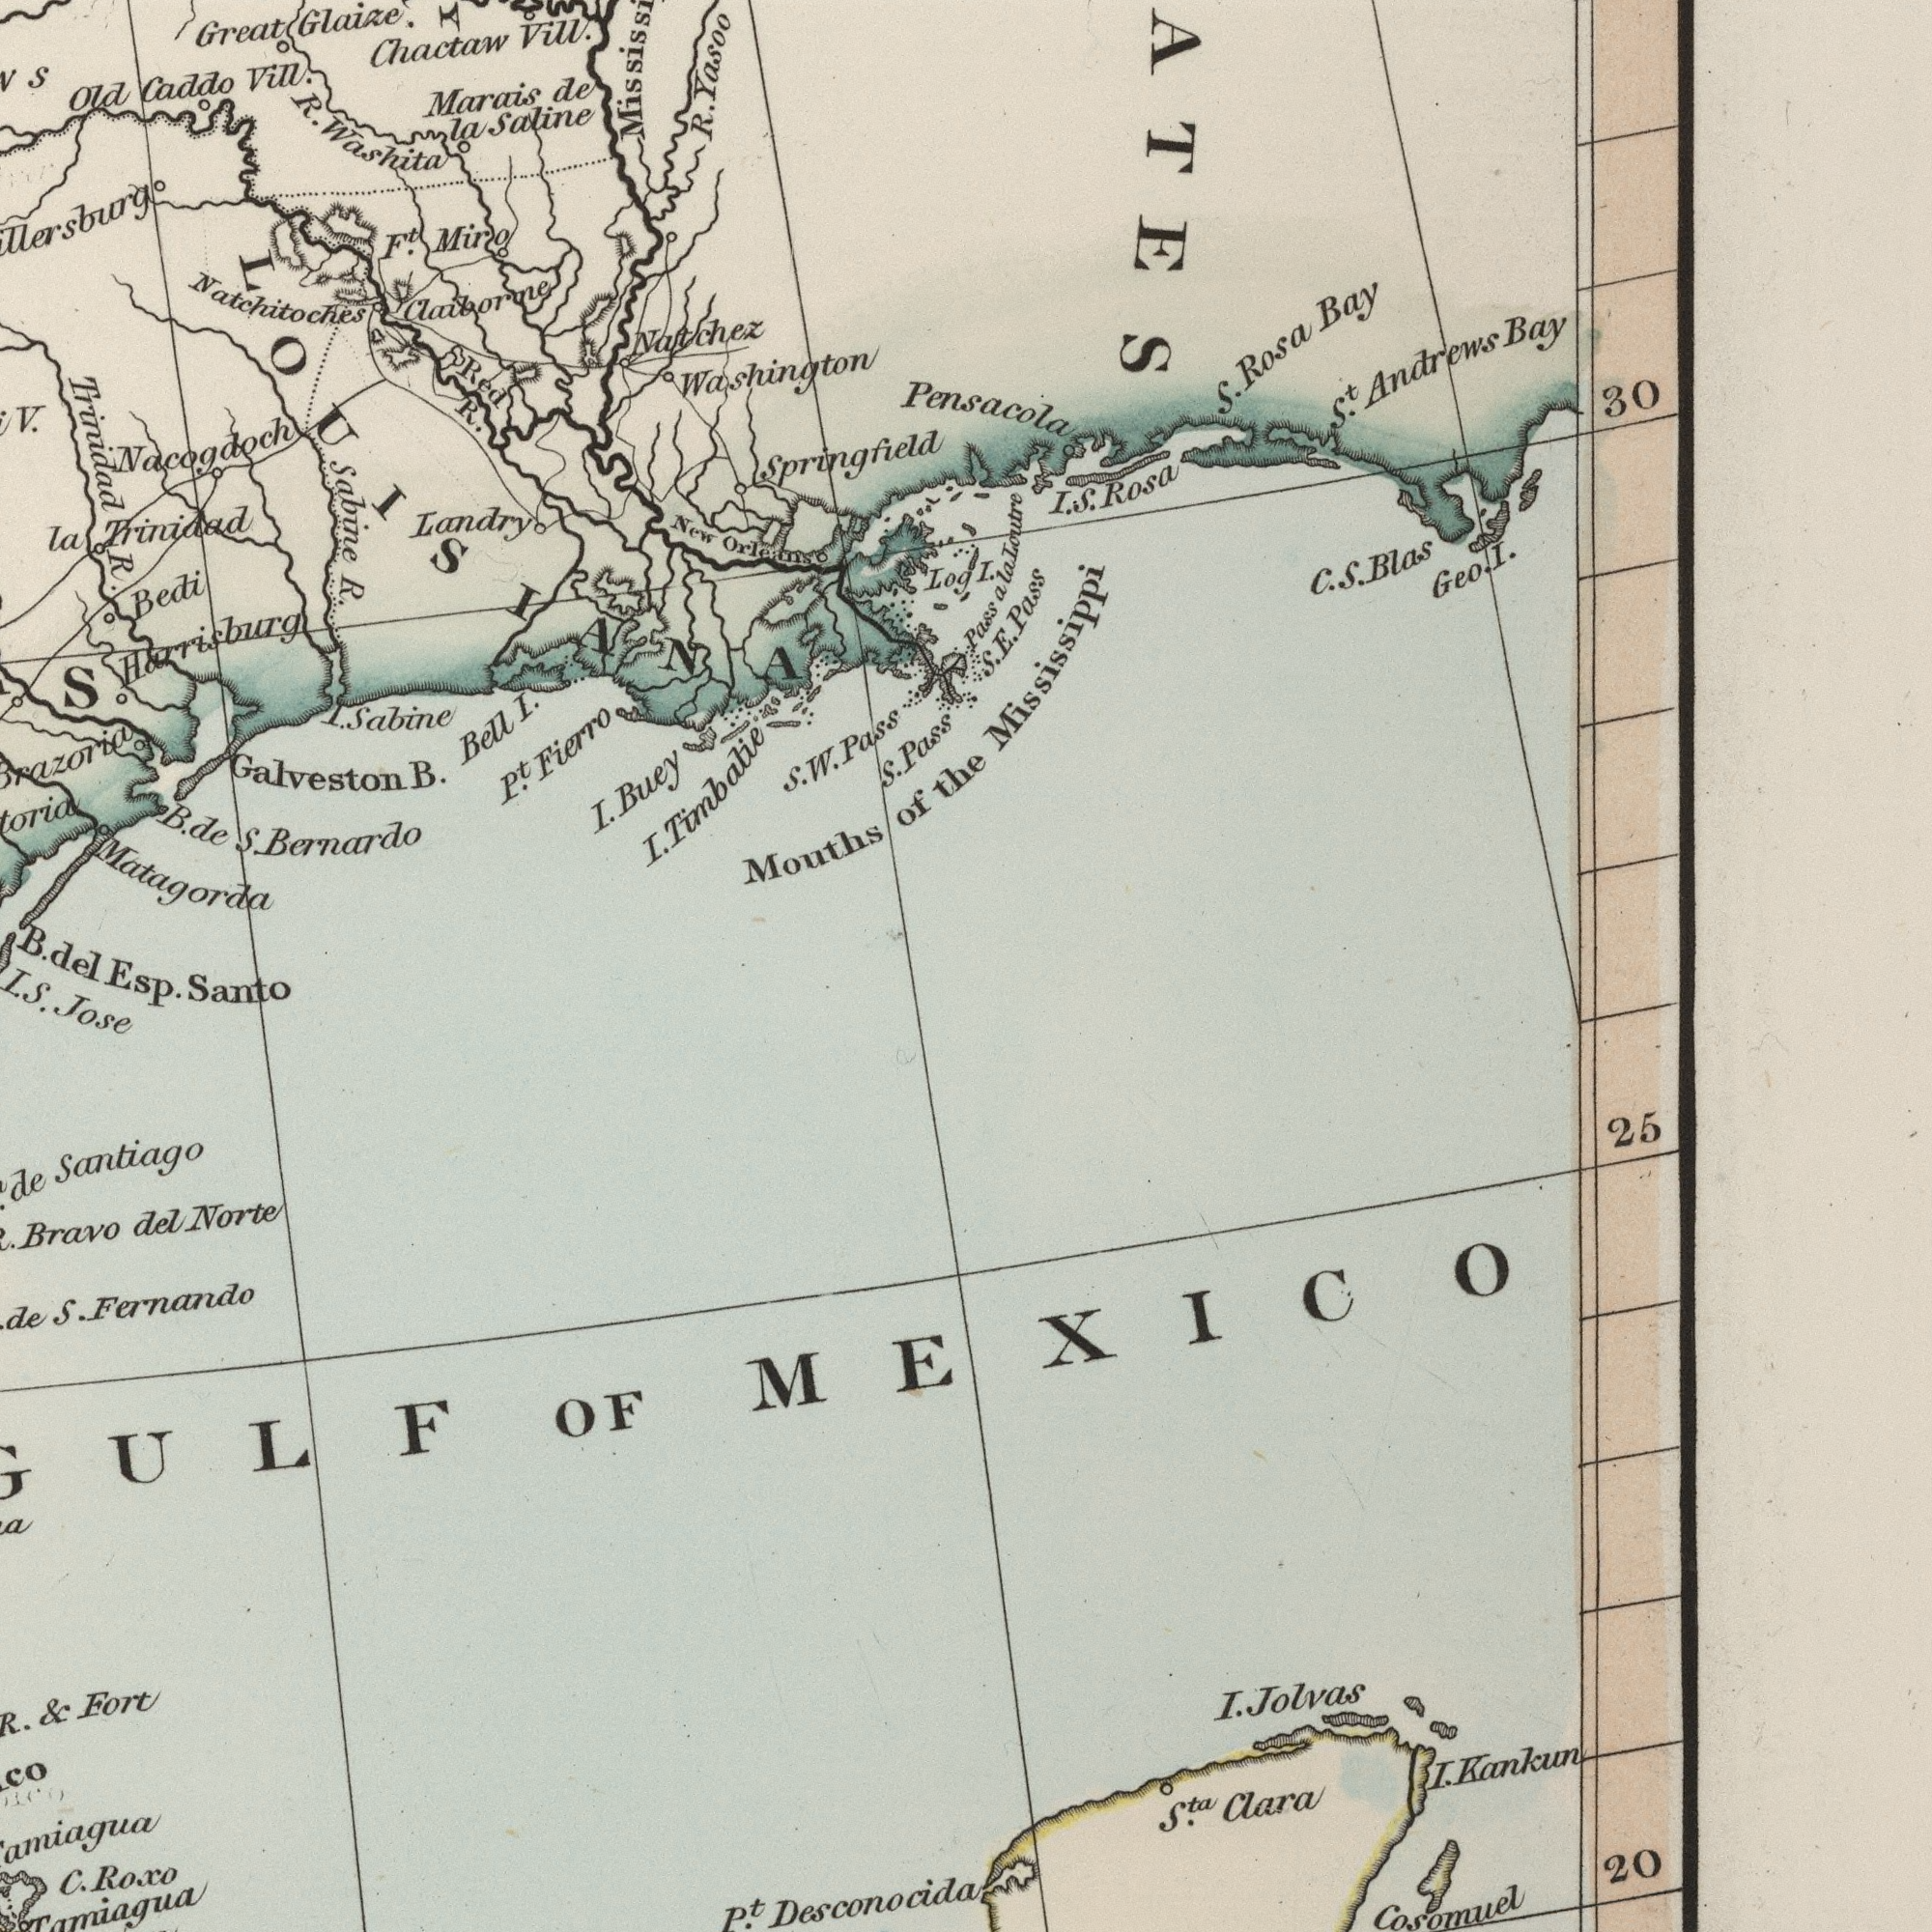What text is visible in the lower-left corner? C. Santo Roxo Tamiagua Esp. I. S. Jose de Santiago Bravo del Norte de S. Fernando GULF OF & Fort P<sup>t</sup>. What text can you see in the top-left section? Natchitoches Trinidad R. R. I. Mouths Trinidad Old R. Natchez Saline Washington Claiborne F<sup>t</sup>. Bedi Landry V. Sabine Marais Buey Orleans Vill. Fierro Great Miro de Nacogdoch Yasoo la I. Red P<sup>t</sup>. Washita R. Bell Galveston New Glaize. Matagorda Harrisburg R. S Chactaw Vill. la I. Caddo Sabine B. I. Timbatie S. W. B. de S. Bernardo B. del. LOUISIANA What text is shown in the top-right quadrant? Springfield Pass S. Andrews Bay Bay Rosa S. Mississippi S<sup>t</sup>. 30 Pensacola Log I. Pass a la Loutre I. S. Rosa C. S. Blas Geo. I. S. E. Pass Pass of the What text appears in the bottom-right area of the image? Cosomuel 25 20 MEXICO I. Jolvas I. Kankun Clara S<sup>ta</sup>. Desconocida 